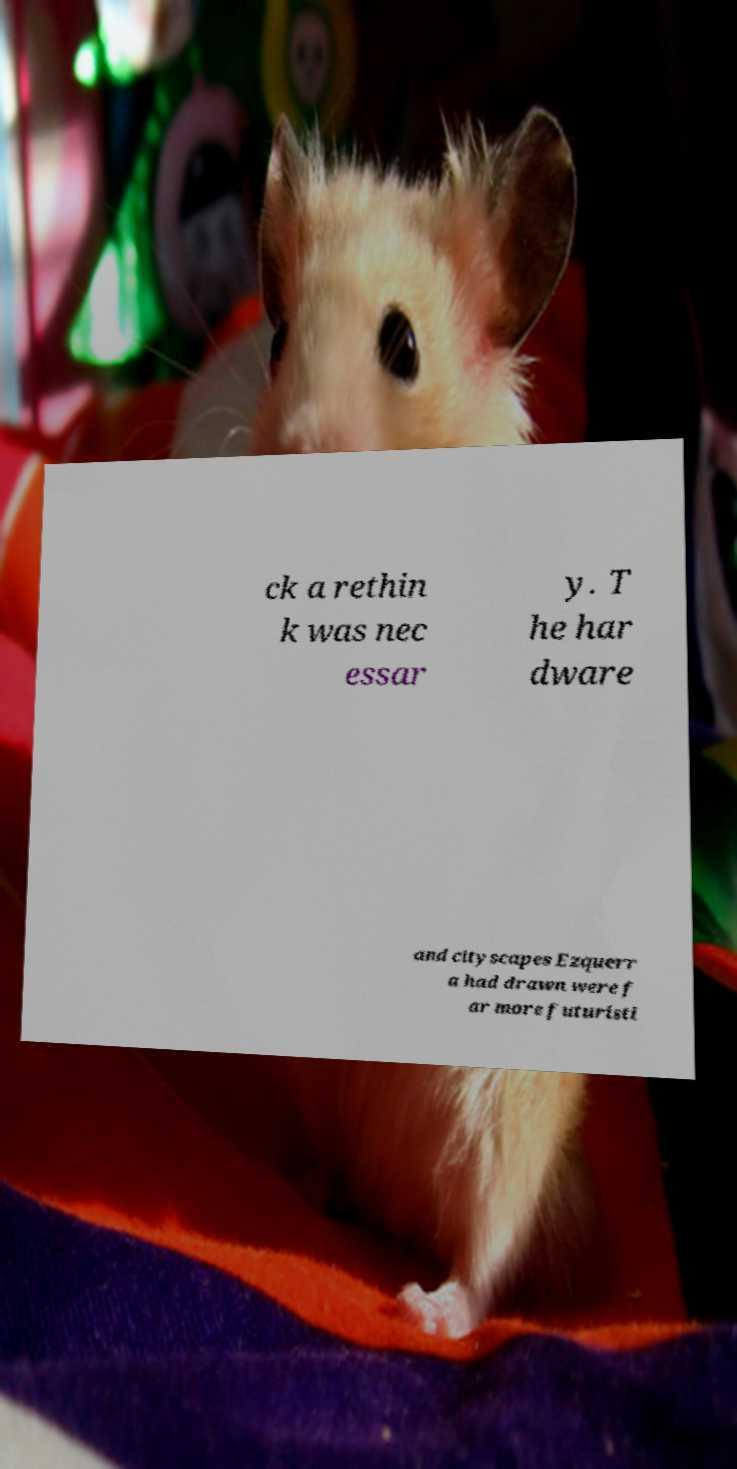There's text embedded in this image that I need extracted. Can you transcribe it verbatim? ck a rethin k was nec essar y. T he har dware and cityscapes Ezquerr a had drawn were f ar more futuristi 